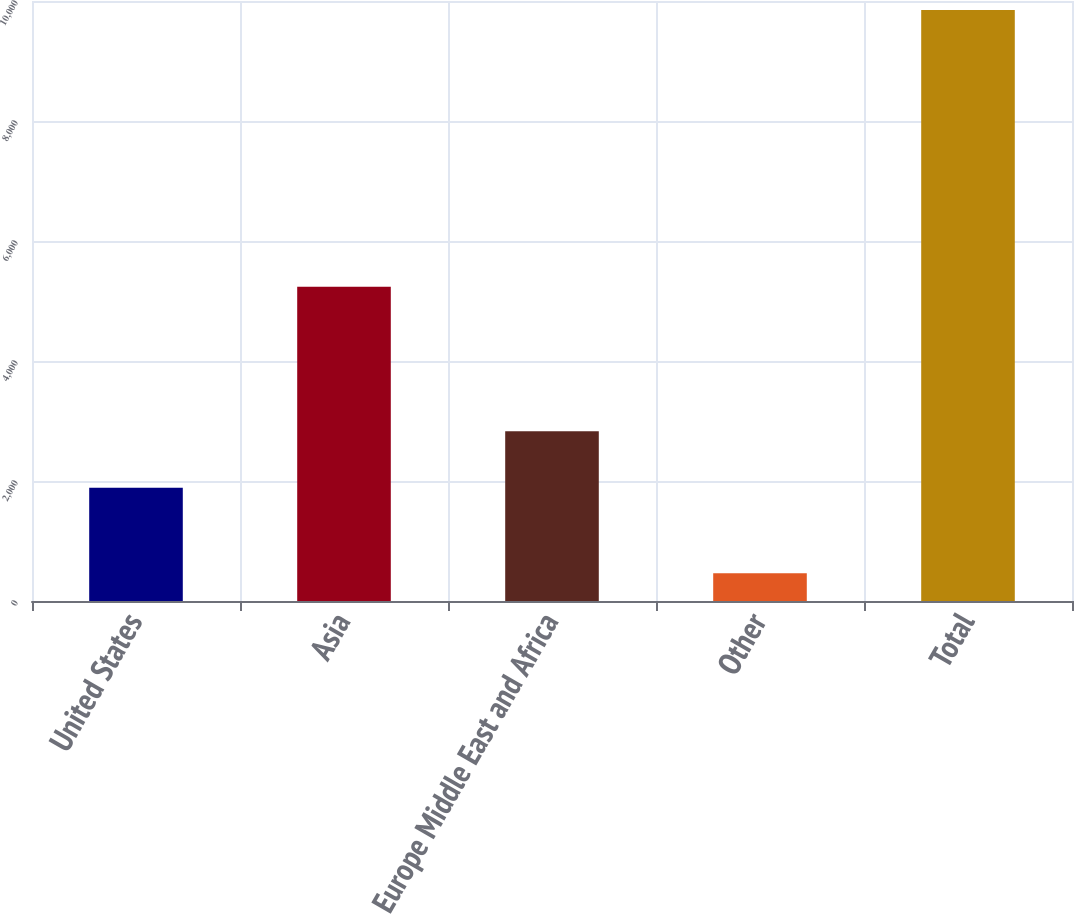Convert chart to OTSL. <chart><loc_0><loc_0><loc_500><loc_500><bar_chart><fcel>United States<fcel>Asia<fcel>Europe Middle East and Africa<fcel>Other<fcel>Total<nl><fcel>1889<fcel>5239<fcel>2827.8<fcel>462<fcel>9850<nl></chart> 